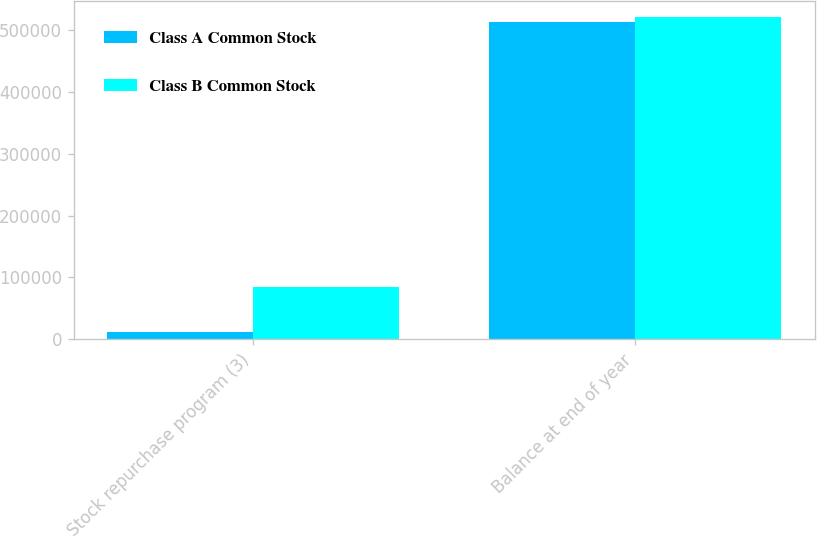Convert chart to OTSL. <chart><loc_0><loc_0><loc_500><loc_500><stacked_bar_chart><ecel><fcel>Stock repurchase program (3)<fcel>Balance at end of year<nl><fcel>Class A Common Stock<fcel>11501<fcel>513399<nl><fcel>Class B Common Stock<fcel>84241<fcel>521543<nl></chart> 